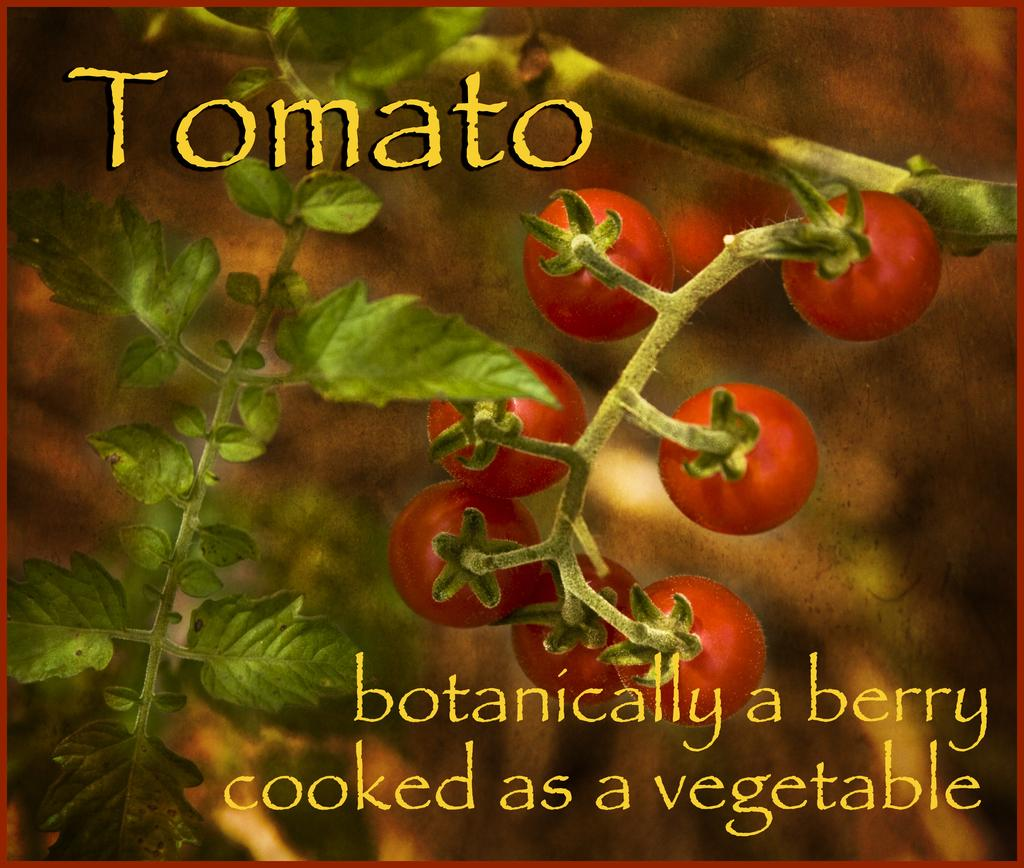What is featured on the poster in the image? The poster contains images of plants and tomatoes. Are there any letters or symbols on the poster? Yes, there are alphabets on the poster. How many ants can be seen crawling on the tomatoes in the image? There are no ants present in the image; it only features images of plants and tomatoes on the poster. 